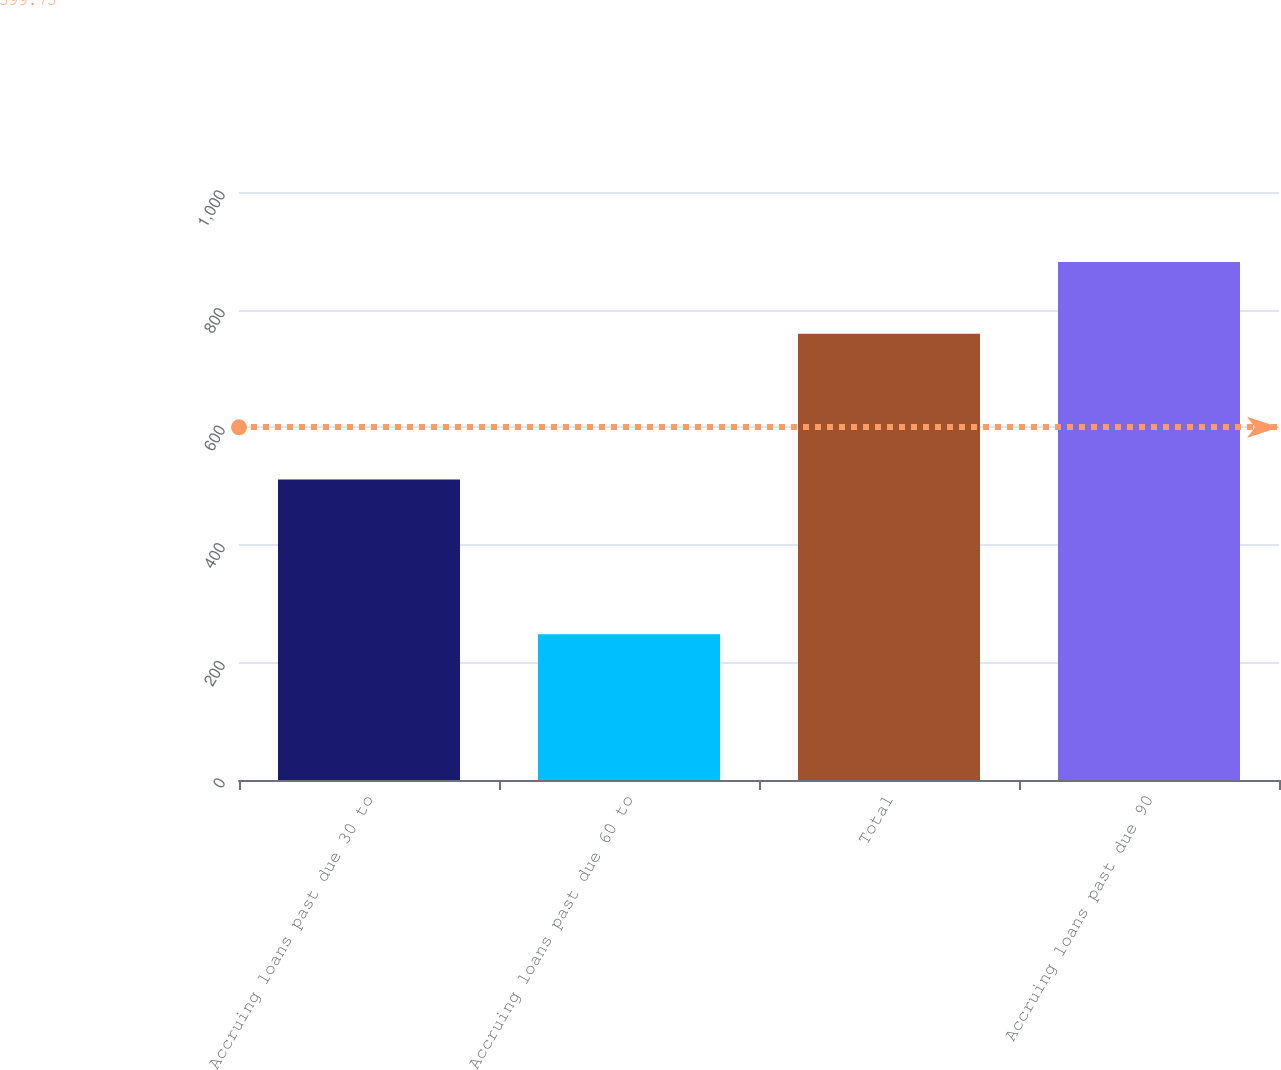<chart> <loc_0><loc_0><loc_500><loc_500><bar_chart><fcel>Accruing loans past due 30 to<fcel>Accruing loans past due 60 to<fcel>Total<fcel>Accruing loans past due 90<nl><fcel>511<fcel>248<fcel>759<fcel>881<nl></chart> 